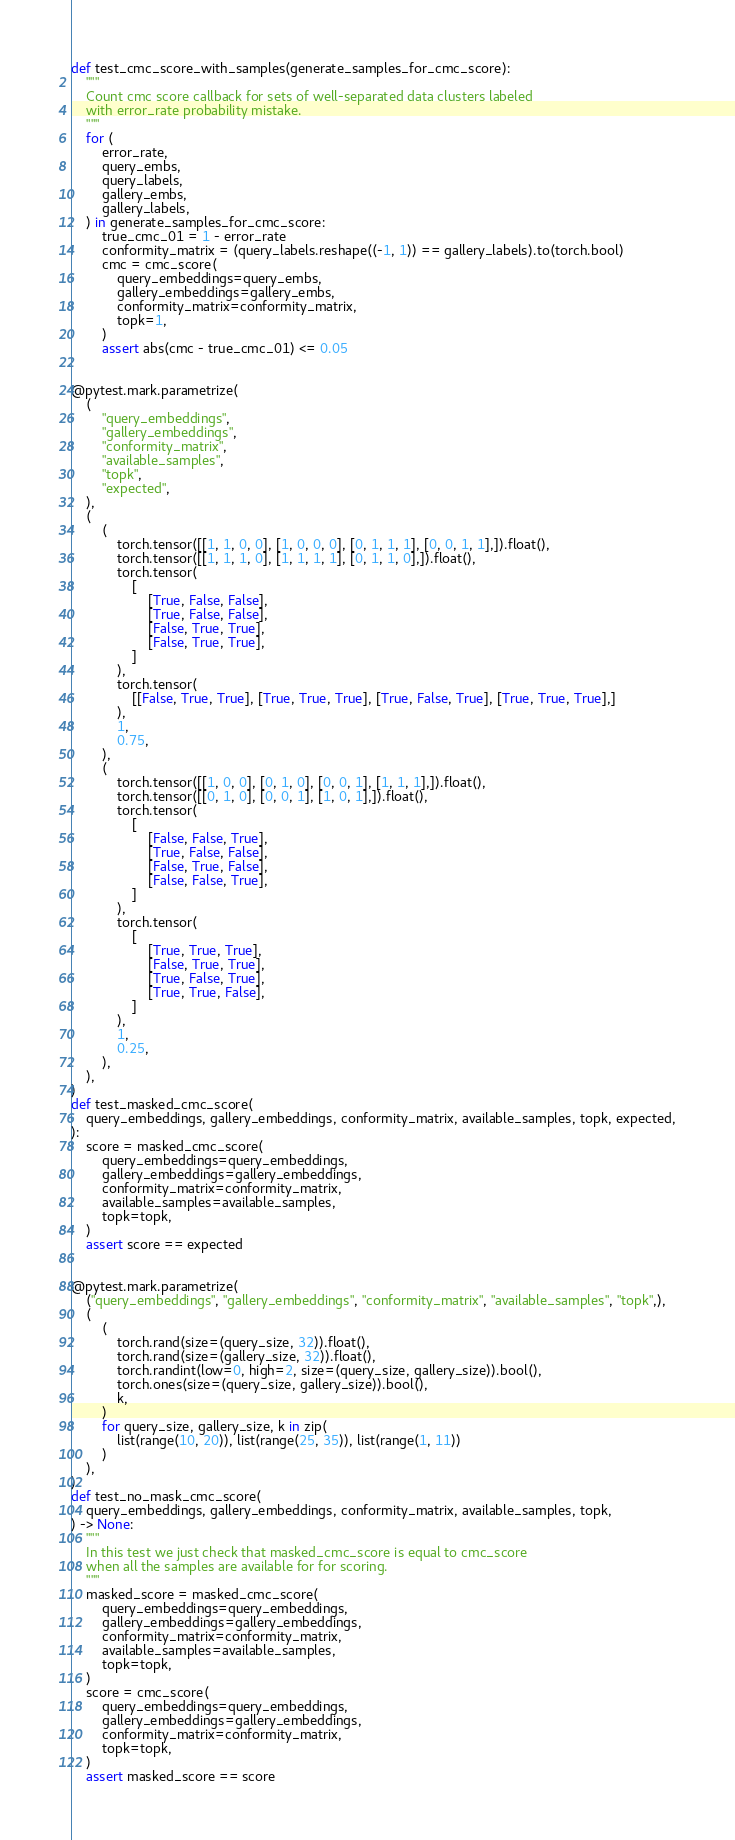<code> <loc_0><loc_0><loc_500><loc_500><_Python_>

def test_cmc_score_with_samples(generate_samples_for_cmc_score):
    """
    Count cmc score callback for sets of well-separated data clusters labeled
    with error_rate probability mistake.
    """
    for (
        error_rate,
        query_embs,
        query_labels,
        gallery_embs,
        gallery_labels,
    ) in generate_samples_for_cmc_score:
        true_cmc_01 = 1 - error_rate
        conformity_matrix = (query_labels.reshape((-1, 1)) == gallery_labels).to(torch.bool)
        cmc = cmc_score(
            query_embeddings=query_embs,
            gallery_embeddings=gallery_embs,
            conformity_matrix=conformity_matrix,
            topk=1,
        )
        assert abs(cmc - true_cmc_01) <= 0.05


@pytest.mark.parametrize(
    (
        "query_embeddings",
        "gallery_embeddings",
        "conformity_matrix",
        "available_samples",
        "topk",
        "expected",
    ),
    (
        (
            torch.tensor([[1, 1, 0, 0], [1, 0, 0, 0], [0, 1, 1, 1], [0, 0, 1, 1],]).float(),
            torch.tensor([[1, 1, 1, 0], [1, 1, 1, 1], [0, 1, 1, 0],]).float(),
            torch.tensor(
                [
                    [True, False, False],
                    [True, False, False],
                    [False, True, True],
                    [False, True, True],
                ]
            ),
            torch.tensor(
                [[False, True, True], [True, True, True], [True, False, True], [True, True, True],]
            ),
            1,
            0.75,
        ),
        (
            torch.tensor([[1, 0, 0], [0, 1, 0], [0, 0, 1], [1, 1, 1],]).float(),
            torch.tensor([[0, 1, 0], [0, 0, 1], [1, 0, 1],]).float(),
            torch.tensor(
                [
                    [False, False, True],
                    [True, False, False],
                    [False, True, False],
                    [False, False, True],
                ]
            ),
            torch.tensor(
                [
                    [True, True, True],
                    [False, True, True],
                    [True, False, True],
                    [True, True, False],
                ]
            ),
            1,
            0.25,
        ),
    ),
)
def test_masked_cmc_score(
    query_embeddings, gallery_embeddings, conformity_matrix, available_samples, topk, expected,
):
    score = masked_cmc_score(
        query_embeddings=query_embeddings,
        gallery_embeddings=gallery_embeddings,
        conformity_matrix=conformity_matrix,
        available_samples=available_samples,
        topk=topk,
    )
    assert score == expected


@pytest.mark.parametrize(
    ("query_embeddings", "gallery_embeddings", "conformity_matrix", "available_samples", "topk",),
    (
        (
            torch.rand(size=(query_size, 32)).float(),
            torch.rand(size=(gallery_size, 32)).float(),
            torch.randint(low=0, high=2, size=(query_size, gallery_size)).bool(),
            torch.ones(size=(query_size, gallery_size)).bool(),
            k,
        )
        for query_size, gallery_size, k in zip(
            list(range(10, 20)), list(range(25, 35)), list(range(1, 11))
        )
    ),
)
def test_no_mask_cmc_score(
    query_embeddings, gallery_embeddings, conformity_matrix, available_samples, topk,
) -> None:
    """
    In this test we just check that masked_cmc_score is equal to cmc_score
    when all the samples are available for for scoring.
    """
    masked_score = masked_cmc_score(
        query_embeddings=query_embeddings,
        gallery_embeddings=gallery_embeddings,
        conformity_matrix=conformity_matrix,
        available_samples=available_samples,
        topk=topk,
    )
    score = cmc_score(
        query_embeddings=query_embeddings,
        gallery_embeddings=gallery_embeddings,
        conformity_matrix=conformity_matrix,
        topk=topk,
    )
    assert masked_score == score
</code> 